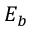<formula> <loc_0><loc_0><loc_500><loc_500>E _ { b }</formula> 